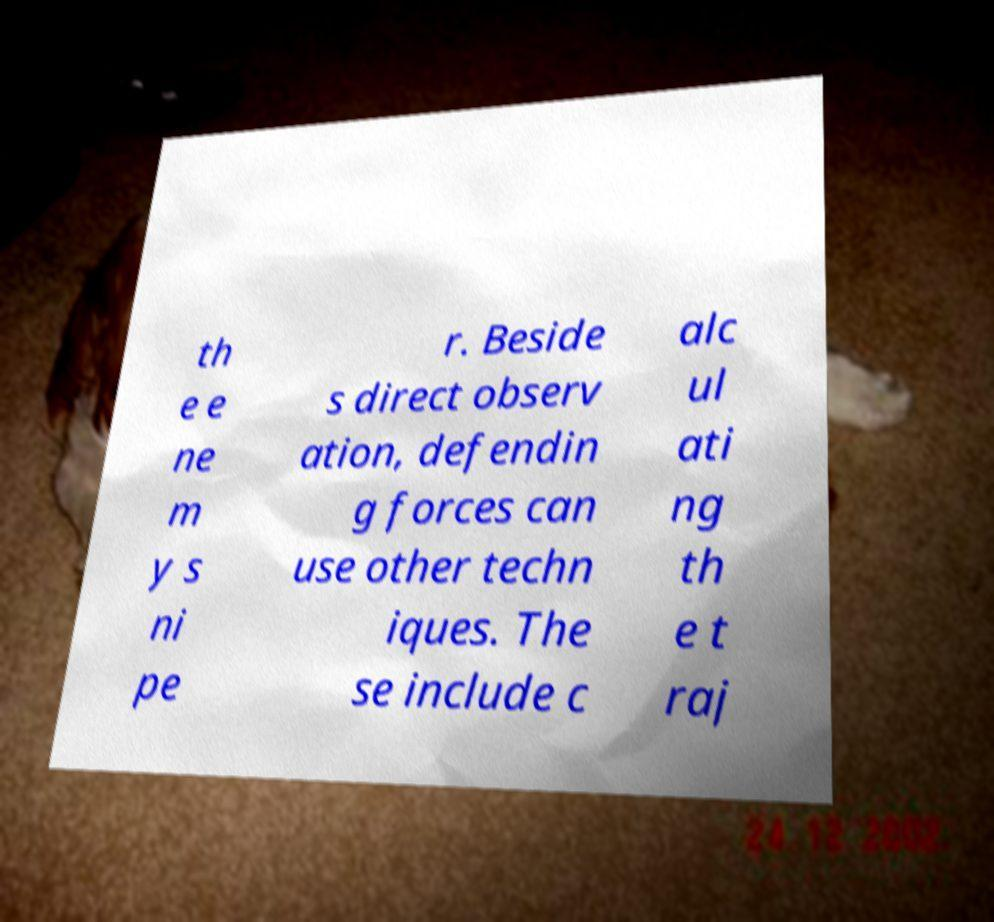Please read and relay the text visible in this image. What does it say? th e e ne m y s ni pe r. Beside s direct observ ation, defendin g forces can use other techn iques. The se include c alc ul ati ng th e t raj 